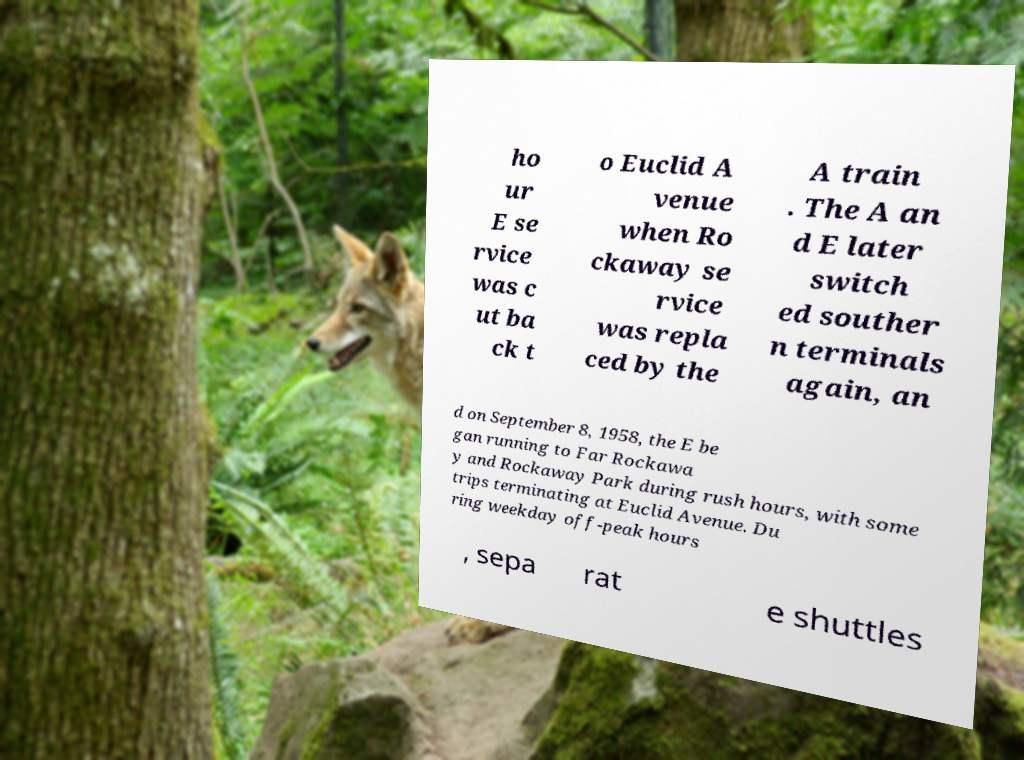For documentation purposes, I need the text within this image transcribed. Could you provide that? ho ur E se rvice was c ut ba ck t o Euclid A venue when Ro ckaway se rvice was repla ced by the A train . The A an d E later switch ed souther n terminals again, an d on September 8, 1958, the E be gan running to Far Rockawa y and Rockaway Park during rush hours, with some trips terminating at Euclid Avenue. Du ring weekday off-peak hours , sepa rat e shuttles 